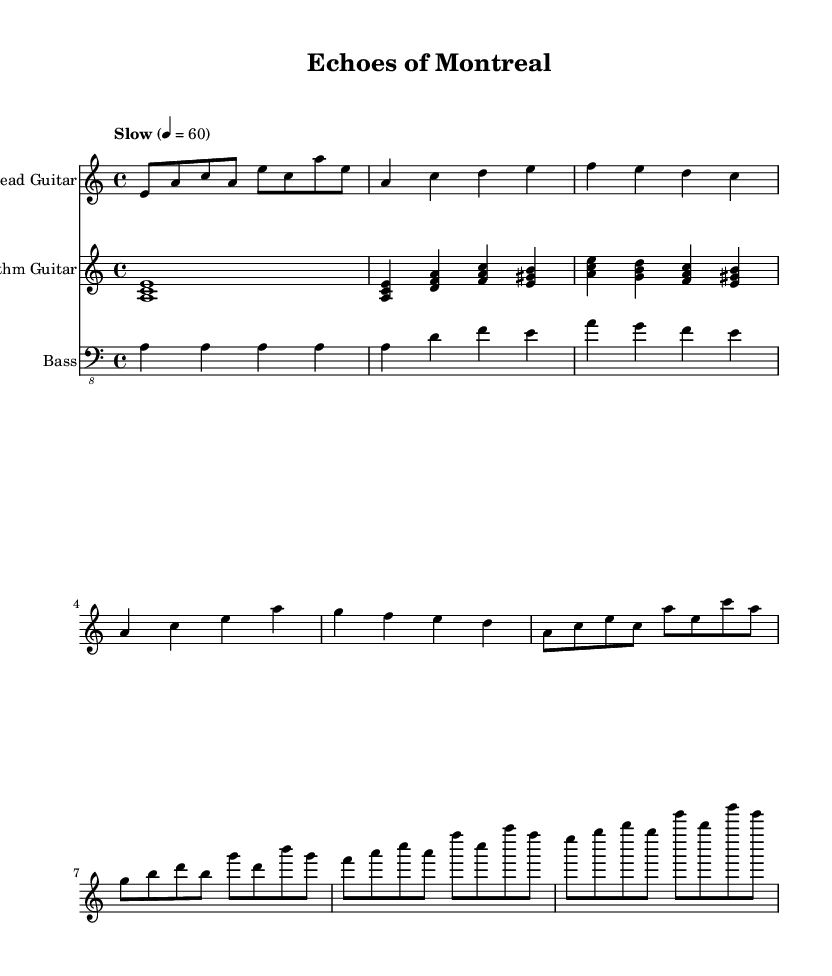What is the key signature of this music? The key signature is indicated as A minor, which has no sharps or flats.
Answer: A minor What is the time signature of this piece? The time signature is shown at the beginning of the music as 4/4, indicating four beats in each measure.
Answer: 4/4 What is the tempo marking for this piece? The tempo marking is "Slow" with a metronome mark of 60 beats per minute, suggesting a relaxed pace.
Answer: Slow Which instrument has the lead melody? The lead melody is performed by the "Lead Guitar," as indicated in the staff’s title.
Answer: Lead Guitar How many measures are included in the chorus section? By analyzing the notation, the chorus consists of four measures.
Answer: 4 What is the emotional tone conveyed by the progression in this electric blues piece? The emotional tone is characterized by bittersweet nostalgia, commonly felt in blues music, specifically reflecting on collaborative writing experiences.
Answer: Bittersweet nostalgia What type of guitar playing style is primarily used in the rhythm guitar part? The rhythm guitar predominantly uses an arpeggiated and simplified strumming pattern characteristic of bluesy styles.
Answer: Arpeggiated and strumming 